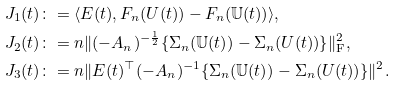<formula> <loc_0><loc_0><loc_500><loc_500>J _ { 1 } ( t ) \colon & = \langle E ( t ) , F _ { n } ( U ( t ) ) - F _ { n } ( \mathbb { U } ( t ) ) \rangle , \\ J _ { 2 } ( t ) \colon & = n \| ( - A _ { n } ) ^ { - \frac { 1 } { 2 } } \{ \Sigma _ { n } ( \mathbb { U } ( t ) ) - \Sigma _ { n } ( U ( t ) ) \} \| ^ { 2 } _ { \mathrm F } , \\ J _ { 3 } ( t ) \colon & = n \| E ( t ) ^ { \top } ( - A _ { n } ) ^ { - 1 } \{ \Sigma _ { n } ( \mathbb { U } ( t ) ) - \Sigma _ { n } ( U ( t ) ) \} \| ^ { 2 } .</formula> 